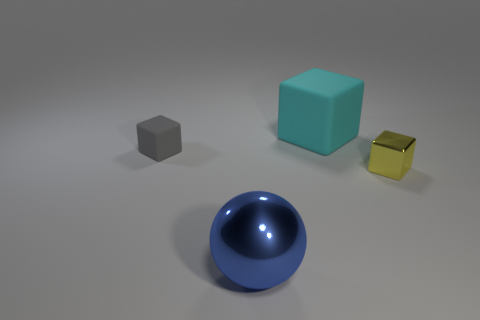Add 3 big shiny blocks. How many objects exist? 7 Subtract all blocks. How many objects are left? 1 Subtract all red metallic cylinders. Subtract all spheres. How many objects are left? 3 Add 3 small yellow objects. How many small yellow objects are left? 4 Add 4 gray matte blocks. How many gray matte blocks exist? 5 Subtract 1 gray cubes. How many objects are left? 3 